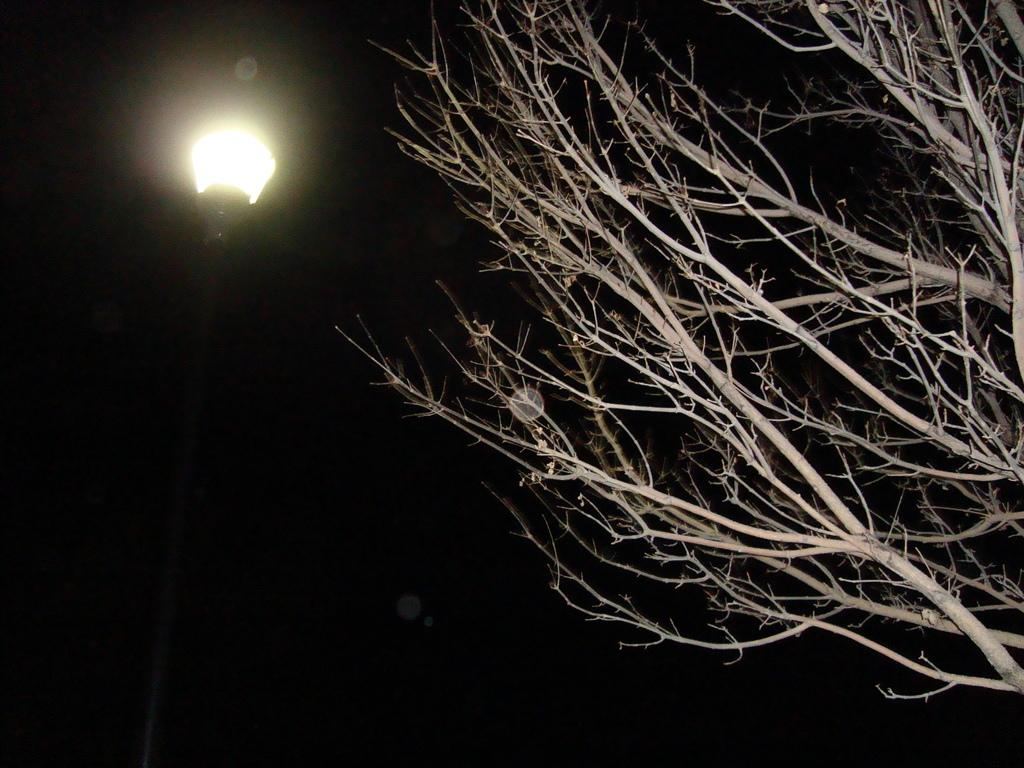What type of plant is present in the image? There is a tree in the image, and it is brown in color. What other object can be seen in the image? There is a black-colored pole in the image. What is on top of the pole? There is a light on top of the pole. What color is the background of the image? The background of the image is black in color. How many gloves can be seen in the image? There are no gloves present in the image. What type of cemetery is visible in the image? There is no cemetery present in the image. 